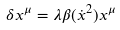Convert formula to latex. <formula><loc_0><loc_0><loc_500><loc_500>\delta x ^ { \mu } = \lambda \beta ( \dot { x } ^ { 2 } ) x ^ { \mu }</formula> 